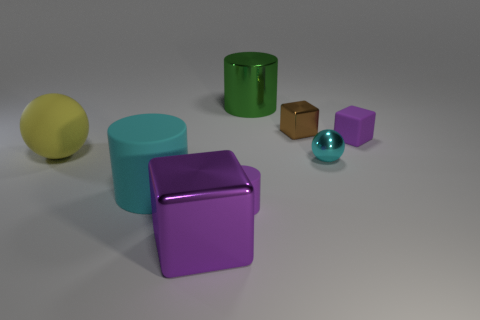There is a big rubber sphere left of the big metal block; does it have the same color as the small sphere?
Give a very brief answer. No. Are there fewer tiny brown metal cubes in front of the small brown metallic object than large green cylinders?
Provide a succinct answer. Yes. What is the color of the big block that is made of the same material as the small brown object?
Offer a very short reply. Purple. There is a matte object right of the tiny brown shiny object; what is its size?
Provide a succinct answer. Small. Do the big sphere and the large purple cube have the same material?
Your answer should be very brief. No. There is a cube right of the tiny brown cube that is to the right of the yellow thing; are there any things behind it?
Provide a succinct answer. Yes. The metallic ball has what color?
Offer a terse response. Cyan. What is the color of the shiny block that is the same size as the green shiny object?
Your response must be concise. Purple. Is the shape of the purple matte thing left of the big metallic cylinder the same as  the cyan metal object?
Give a very brief answer. No. What color is the big cylinder to the left of the shiny cube in front of the purple block to the right of the brown object?
Keep it short and to the point. Cyan. 